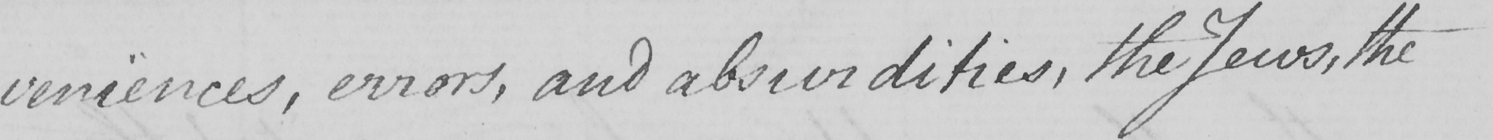Please provide the text content of this handwritten line. -veniences , errors , and absurdities , the Jews , the 